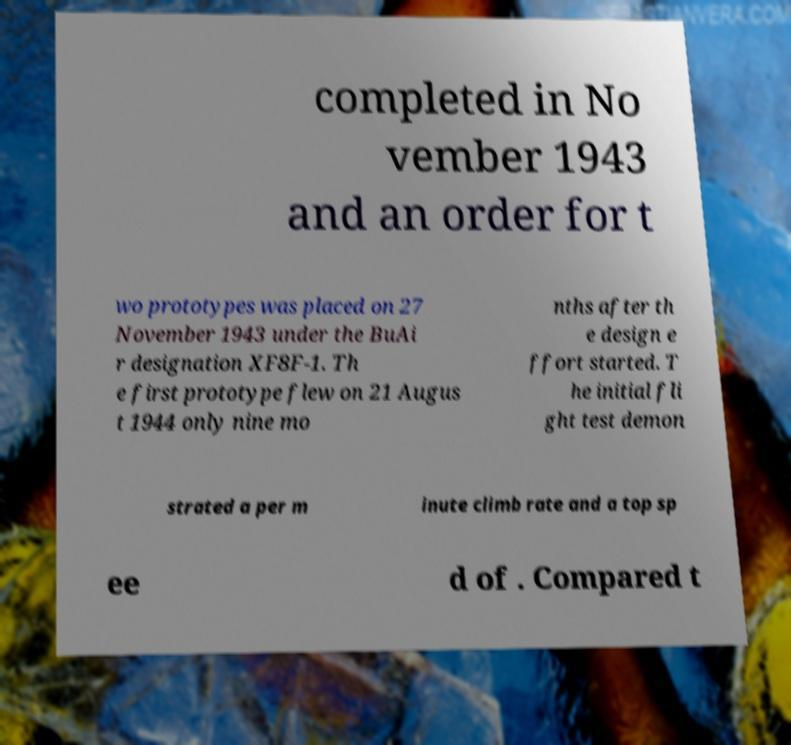Could you assist in decoding the text presented in this image and type it out clearly? completed in No vember 1943 and an order for t wo prototypes was placed on 27 November 1943 under the BuAi r designation XF8F-1. Th e first prototype flew on 21 Augus t 1944 only nine mo nths after th e design e ffort started. T he initial fli ght test demon strated a per m inute climb rate and a top sp ee d of . Compared t 